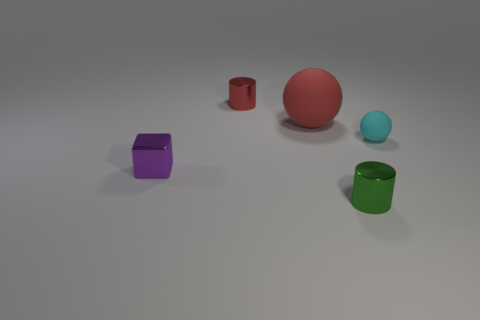How many objects are there in total in the image? There are a total of five objects in the image, each varying in color and shape. 